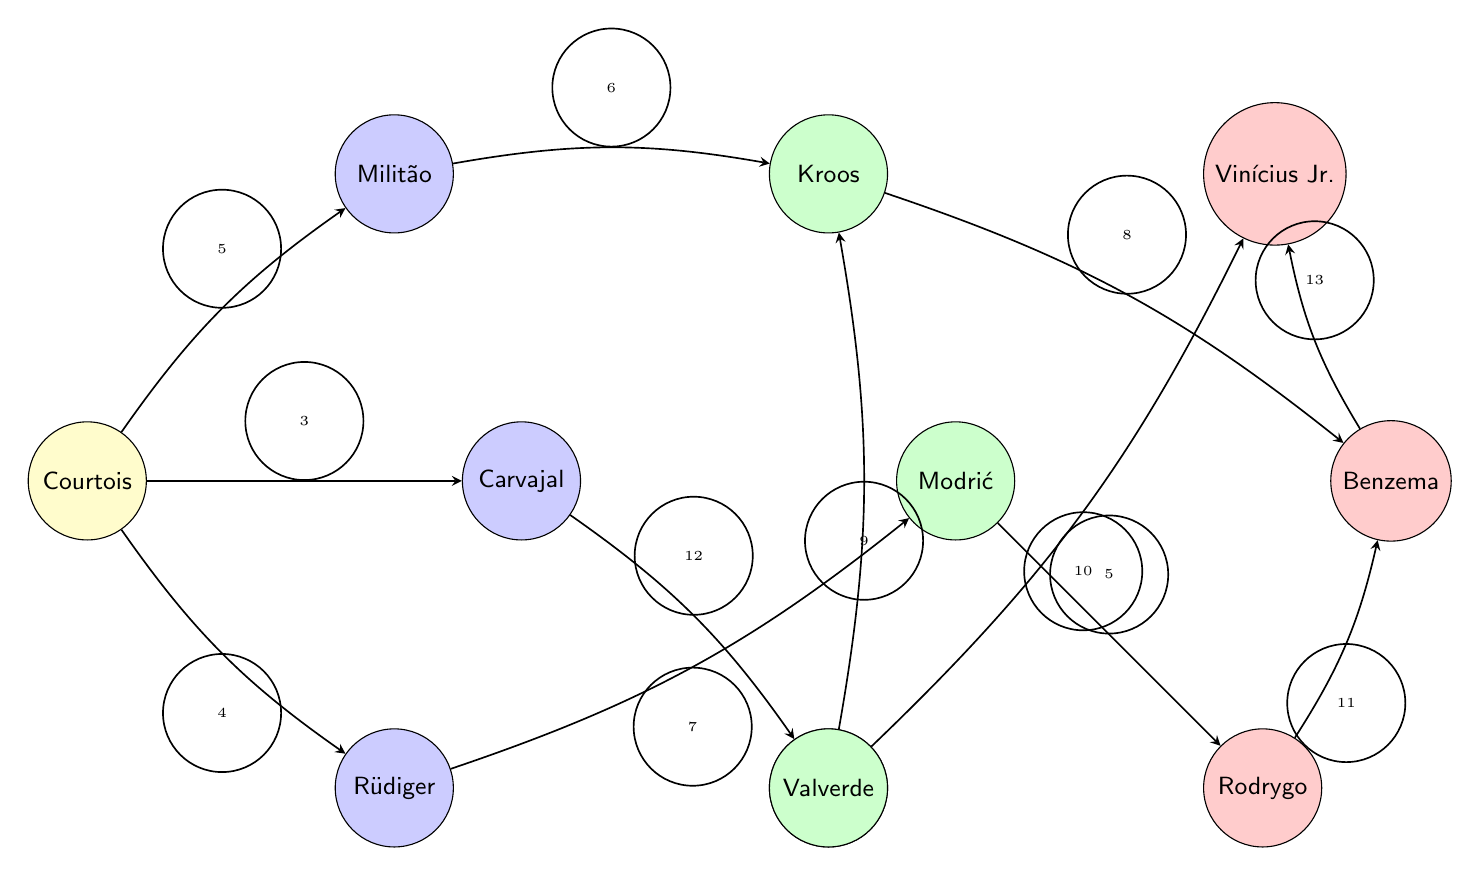What's the total number of players in the diagram? The diagram lists 11 players, each represented as a node. Counting them will yield the total.
Answer: 11 Which player has the highest number of key passes recorded in the diagram? The edge connecting Benzema to Vinicius has the highest value of 13, indicating that Benzema made the most key passes.
Answer: Benzema How many passes did Carvajal make to Valverde? The edge between Carvajal and Valverde shows a value of 12, indicating the number of passes made in that direction.
Answer: 12 Which player received the most passes from Courtois? The edges from Courtois indicate the values: to Militao (5), Rudiger (4), and Carvajal (3). Militao has the highest value (5).
Answer: Militao Identify two midfielders who made a significant connection through passes in the diagram. The connections from Kroos (to Benzema with 8) and Valverde (to Kroos with 9) indicate significant interactions among midfielders.
Answer: Kroos and Valverde Which player is the main receiver of passes from Mendy? The edge from Mendy to Vinicius shows the value of 10, which indicates the most passes received from Mendy.
Answer: Vinicius How many connections did Benzema make to other players? Benzema is shown to have two outgoing connections: to Vinicius (13) and to Rodrygo (11), giving a total of two connections.
Answer: 2 What position does Thibaut Courtois play as indicated in the diagram? The diagram explicitly labels Thibaut Courtois’s position as Goalkeeper.
Answer: Goalkeeper Which defender made the most key passes to teammates? Looking at the edges from defenders: Carvajal (12), Rudiger (7), and Militao (6), the highest number is from Carvajal.
Answer: Carvajal 